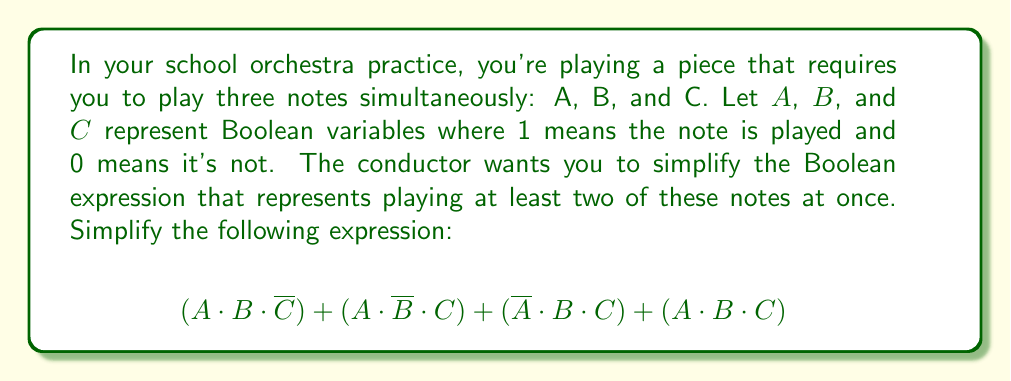Can you solve this math problem? Let's simplify this Boolean expression step by step:

1) First, let's recognize that this expression represents all cases where at least two notes are played simultaneously. The last term $(A \cdot B \cdot C)$ represents all three notes being played.

2) We can simplify this using the absorption law of Boolean algebra. This law states that $X + (X \cdot Y) = X$ for any Boolean variables $X$ and $Y$.

3) Let's apply this to our expression:
   $$(A \cdot B) + (A \cdot C) + (B \cdot C)$$

   This is because each term in our original expression is absorbed by one of these simpler terms. For example, $(A \cdot B \cdot \overline{C})$ is absorbed by $(A \cdot B)$.

4) This simplified expression $(A \cdot B) + (A \cdot C) + (B \cdot C)$ is known as the "majority function" for three variables. It returns true when at least two of the three variables are true.

5) This expression cannot be simplified further using Boolean algebra laws.

Therefore, the simplified Boolean expression for playing at least two notes simultaneously is $(A \cdot B) + (A \cdot C) + (B \cdot C)$.
Answer: $(A \cdot B) + (A \cdot C) + (B \cdot C)$ 